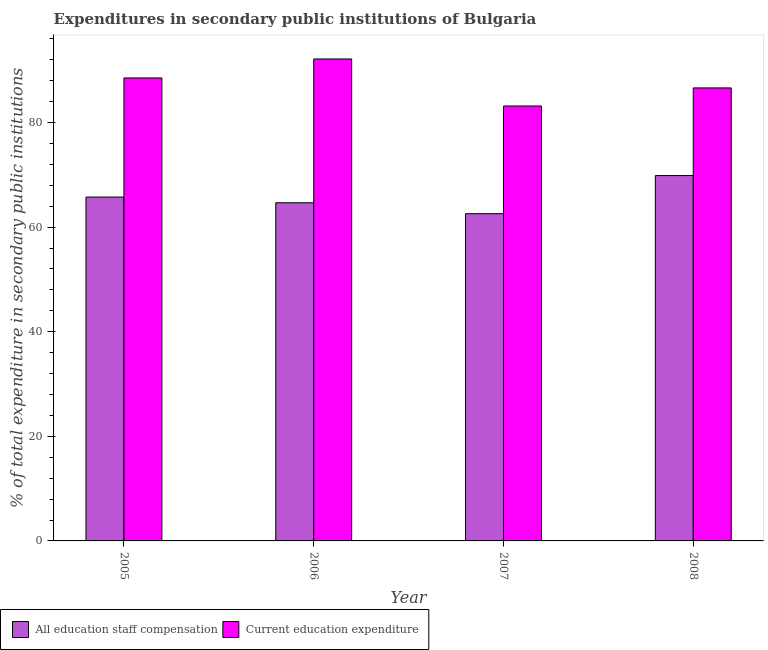How many different coloured bars are there?
Give a very brief answer. 2. Are the number of bars on each tick of the X-axis equal?
Your answer should be compact. Yes. How many bars are there on the 4th tick from the left?
Your answer should be compact. 2. What is the label of the 3rd group of bars from the left?
Your answer should be compact. 2007. In how many cases, is the number of bars for a given year not equal to the number of legend labels?
Your response must be concise. 0. What is the expenditure in staff compensation in 2006?
Give a very brief answer. 64.66. Across all years, what is the maximum expenditure in education?
Provide a short and direct response. 92.15. Across all years, what is the minimum expenditure in staff compensation?
Your response must be concise. 62.57. In which year was the expenditure in staff compensation maximum?
Keep it short and to the point. 2008. In which year was the expenditure in education minimum?
Your response must be concise. 2007. What is the total expenditure in education in the graph?
Provide a short and direct response. 350.46. What is the difference between the expenditure in staff compensation in 2007 and that in 2008?
Your answer should be compact. -7.29. What is the difference between the expenditure in education in 2005 and the expenditure in staff compensation in 2008?
Your answer should be very brief. 1.91. What is the average expenditure in education per year?
Keep it short and to the point. 87.62. In the year 2008, what is the difference between the expenditure in education and expenditure in staff compensation?
Your response must be concise. 0. What is the ratio of the expenditure in education in 2005 to that in 2008?
Give a very brief answer. 1.02. Is the difference between the expenditure in education in 2007 and 2008 greater than the difference between the expenditure in staff compensation in 2007 and 2008?
Give a very brief answer. No. What is the difference between the highest and the second highest expenditure in education?
Provide a short and direct response. 3.63. What is the difference between the highest and the lowest expenditure in staff compensation?
Provide a short and direct response. 7.29. In how many years, is the expenditure in staff compensation greater than the average expenditure in staff compensation taken over all years?
Your response must be concise. 2. What does the 2nd bar from the left in 2007 represents?
Your response must be concise. Current education expenditure. What does the 1st bar from the right in 2005 represents?
Offer a terse response. Current education expenditure. How many bars are there?
Keep it short and to the point. 8. Are all the bars in the graph horizontal?
Your answer should be compact. No. How many years are there in the graph?
Your answer should be compact. 4. What is the difference between two consecutive major ticks on the Y-axis?
Provide a short and direct response. 20. Are the values on the major ticks of Y-axis written in scientific E-notation?
Make the answer very short. No. Does the graph contain grids?
Offer a very short reply. No. Where does the legend appear in the graph?
Your answer should be compact. Bottom left. How many legend labels are there?
Make the answer very short. 2. How are the legend labels stacked?
Offer a terse response. Horizontal. What is the title of the graph?
Your answer should be compact. Expenditures in secondary public institutions of Bulgaria. What is the label or title of the Y-axis?
Provide a succinct answer. % of total expenditure in secondary public institutions. What is the % of total expenditure in secondary public institutions in All education staff compensation in 2005?
Your response must be concise. 65.75. What is the % of total expenditure in secondary public institutions of Current education expenditure in 2005?
Your answer should be compact. 88.53. What is the % of total expenditure in secondary public institutions of All education staff compensation in 2006?
Give a very brief answer. 64.66. What is the % of total expenditure in secondary public institutions of Current education expenditure in 2006?
Offer a terse response. 92.15. What is the % of total expenditure in secondary public institutions in All education staff compensation in 2007?
Give a very brief answer. 62.57. What is the % of total expenditure in secondary public institutions of Current education expenditure in 2007?
Offer a very short reply. 83.16. What is the % of total expenditure in secondary public institutions of All education staff compensation in 2008?
Provide a short and direct response. 69.86. What is the % of total expenditure in secondary public institutions in Current education expenditure in 2008?
Offer a terse response. 86.62. Across all years, what is the maximum % of total expenditure in secondary public institutions of All education staff compensation?
Give a very brief answer. 69.86. Across all years, what is the maximum % of total expenditure in secondary public institutions of Current education expenditure?
Your response must be concise. 92.15. Across all years, what is the minimum % of total expenditure in secondary public institutions of All education staff compensation?
Your answer should be very brief. 62.57. Across all years, what is the minimum % of total expenditure in secondary public institutions in Current education expenditure?
Your response must be concise. 83.16. What is the total % of total expenditure in secondary public institutions of All education staff compensation in the graph?
Provide a short and direct response. 262.85. What is the total % of total expenditure in secondary public institutions of Current education expenditure in the graph?
Ensure brevity in your answer.  350.46. What is the difference between the % of total expenditure in secondary public institutions in All education staff compensation in 2005 and that in 2006?
Ensure brevity in your answer.  1.09. What is the difference between the % of total expenditure in secondary public institutions in Current education expenditure in 2005 and that in 2006?
Ensure brevity in your answer.  -3.63. What is the difference between the % of total expenditure in secondary public institutions of All education staff compensation in 2005 and that in 2007?
Make the answer very short. 3.18. What is the difference between the % of total expenditure in secondary public institutions in Current education expenditure in 2005 and that in 2007?
Your answer should be very brief. 5.37. What is the difference between the % of total expenditure in secondary public institutions in All education staff compensation in 2005 and that in 2008?
Offer a very short reply. -4.11. What is the difference between the % of total expenditure in secondary public institutions of Current education expenditure in 2005 and that in 2008?
Offer a terse response. 1.91. What is the difference between the % of total expenditure in secondary public institutions in All education staff compensation in 2006 and that in 2007?
Keep it short and to the point. 2.09. What is the difference between the % of total expenditure in secondary public institutions in Current education expenditure in 2006 and that in 2007?
Make the answer very short. 8.99. What is the difference between the % of total expenditure in secondary public institutions in All education staff compensation in 2006 and that in 2008?
Offer a very short reply. -5.2. What is the difference between the % of total expenditure in secondary public institutions of Current education expenditure in 2006 and that in 2008?
Offer a very short reply. 5.53. What is the difference between the % of total expenditure in secondary public institutions in All education staff compensation in 2007 and that in 2008?
Your answer should be very brief. -7.29. What is the difference between the % of total expenditure in secondary public institutions of Current education expenditure in 2007 and that in 2008?
Offer a terse response. -3.46. What is the difference between the % of total expenditure in secondary public institutions of All education staff compensation in 2005 and the % of total expenditure in secondary public institutions of Current education expenditure in 2006?
Your answer should be compact. -26.4. What is the difference between the % of total expenditure in secondary public institutions of All education staff compensation in 2005 and the % of total expenditure in secondary public institutions of Current education expenditure in 2007?
Your answer should be compact. -17.41. What is the difference between the % of total expenditure in secondary public institutions in All education staff compensation in 2005 and the % of total expenditure in secondary public institutions in Current education expenditure in 2008?
Give a very brief answer. -20.87. What is the difference between the % of total expenditure in secondary public institutions of All education staff compensation in 2006 and the % of total expenditure in secondary public institutions of Current education expenditure in 2007?
Keep it short and to the point. -18.5. What is the difference between the % of total expenditure in secondary public institutions of All education staff compensation in 2006 and the % of total expenditure in secondary public institutions of Current education expenditure in 2008?
Provide a succinct answer. -21.96. What is the difference between the % of total expenditure in secondary public institutions in All education staff compensation in 2007 and the % of total expenditure in secondary public institutions in Current education expenditure in 2008?
Your answer should be very brief. -24.05. What is the average % of total expenditure in secondary public institutions of All education staff compensation per year?
Offer a very short reply. 65.71. What is the average % of total expenditure in secondary public institutions in Current education expenditure per year?
Provide a succinct answer. 87.62. In the year 2005, what is the difference between the % of total expenditure in secondary public institutions of All education staff compensation and % of total expenditure in secondary public institutions of Current education expenditure?
Give a very brief answer. -22.77. In the year 2006, what is the difference between the % of total expenditure in secondary public institutions of All education staff compensation and % of total expenditure in secondary public institutions of Current education expenditure?
Offer a terse response. -27.49. In the year 2007, what is the difference between the % of total expenditure in secondary public institutions in All education staff compensation and % of total expenditure in secondary public institutions in Current education expenditure?
Provide a short and direct response. -20.59. In the year 2008, what is the difference between the % of total expenditure in secondary public institutions of All education staff compensation and % of total expenditure in secondary public institutions of Current education expenditure?
Give a very brief answer. -16.76. What is the ratio of the % of total expenditure in secondary public institutions of All education staff compensation in 2005 to that in 2006?
Your answer should be compact. 1.02. What is the ratio of the % of total expenditure in secondary public institutions in Current education expenditure in 2005 to that in 2006?
Ensure brevity in your answer.  0.96. What is the ratio of the % of total expenditure in secondary public institutions of All education staff compensation in 2005 to that in 2007?
Offer a very short reply. 1.05. What is the ratio of the % of total expenditure in secondary public institutions in Current education expenditure in 2005 to that in 2007?
Provide a short and direct response. 1.06. What is the ratio of the % of total expenditure in secondary public institutions of Current education expenditure in 2005 to that in 2008?
Your response must be concise. 1.02. What is the ratio of the % of total expenditure in secondary public institutions of All education staff compensation in 2006 to that in 2007?
Make the answer very short. 1.03. What is the ratio of the % of total expenditure in secondary public institutions of Current education expenditure in 2006 to that in 2007?
Offer a terse response. 1.11. What is the ratio of the % of total expenditure in secondary public institutions in All education staff compensation in 2006 to that in 2008?
Keep it short and to the point. 0.93. What is the ratio of the % of total expenditure in secondary public institutions of Current education expenditure in 2006 to that in 2008?
Provide a short and direct response. 1.06. What is the ratio of the % of total expenditure in secondary public institutions of All education staff compensation in 2007 to that in 2008?
Your answer should be compact. 0.9. What is the ratio of the % of total expenditure in secondary public institutions in Current education expenditure in 2007 to that in 2008?
Give a very brief answer. 0.96. What is the difference between the highest and the second highest % of total expenditure in secondary public institutions in All education staff compensation?
Your response must be concise. 4.11. What is the difference between the highest and the second highest % of total expenditure in secondary public institutions of Current education expenditure?
Provide a short and direct response. 3.63. What is the difference between the highest and the lowest % of total expenditure in secondary public institutions in All education staff compensation?
Your answer should be very brief. 7.29. What is the difference between the highest and the lowest % of total expenditure in secondary public institutions of Current education expenditure?
Provide a short and direct response. 8.99. 